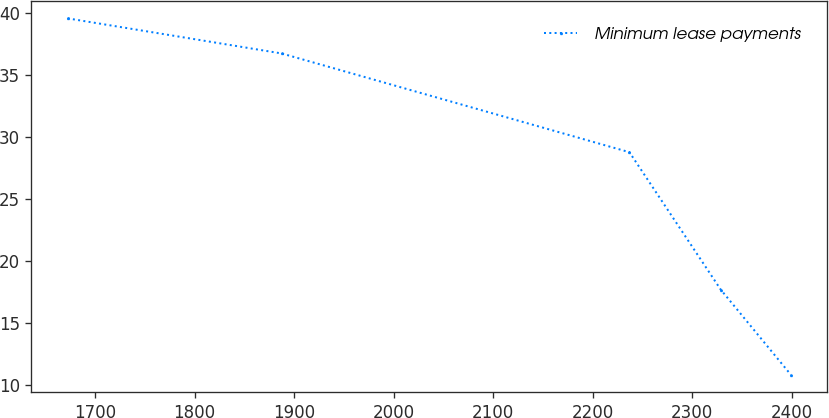Convert chart. <chart><loc_0><loc_0><loc_500><loc_500><line_chart><ecel><fcel>Minimum lease payments<nl><fcel>1672.56<fcel>39.56<nl><fcel>1887.42<fcel>36.73<nl><fcel>2236.79<fcel>28.76<nl><fcel>2328.43<fcel>17.68<nl><fcel>2398.86<fcel>10.81<nl></chart> 